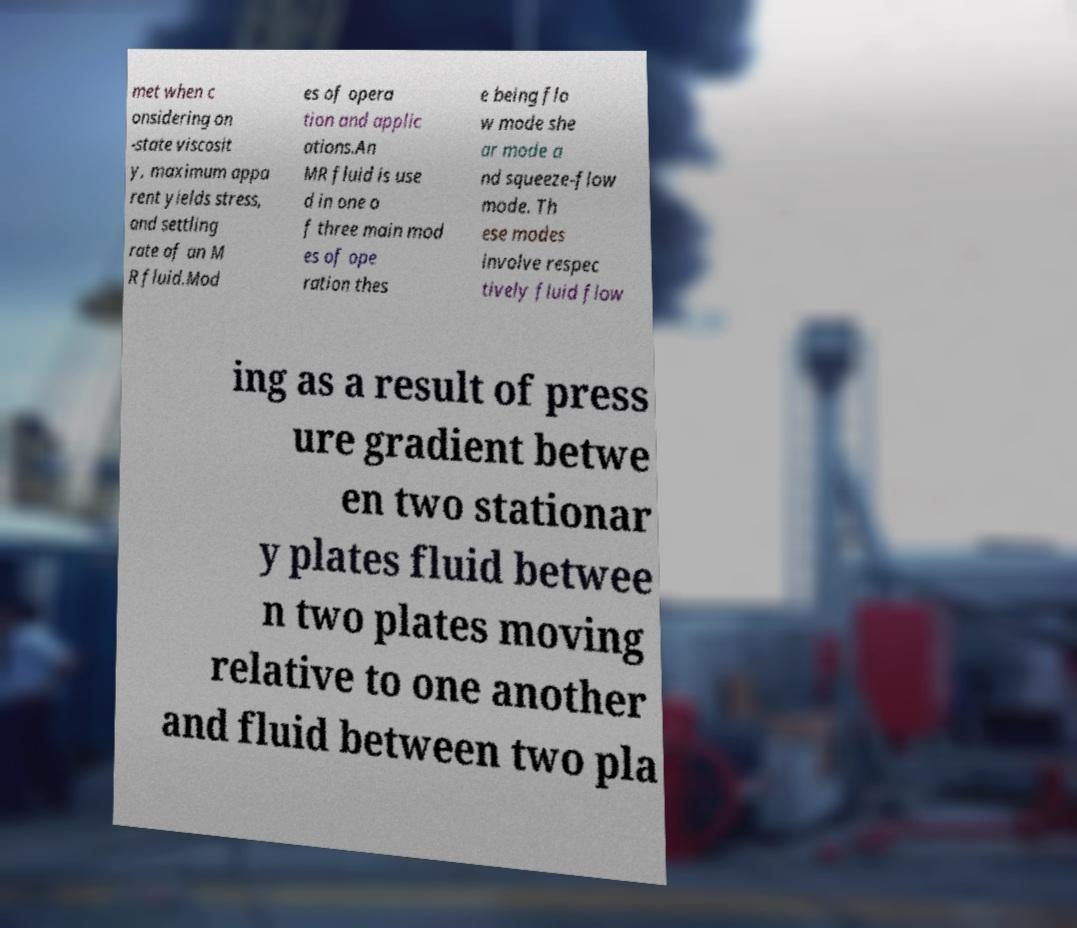Could you extract and type out the text from this image? met when c onsidering on -state viscosit y, maximum appa rent yields stress, and settling rate of an M R fluid.Mod es of opera tion and applic ations.An MR fluid is use d in one o f three main mod es of ope ration thes e being flo w mode she ar mode a nd squeeze-flow mode. Th ese modes involve respec tively fluid flow ing as a result of press ure gradient betwe en two stationar y plates fluid betwee n two plates moving relative to one another and fluid between two pla 